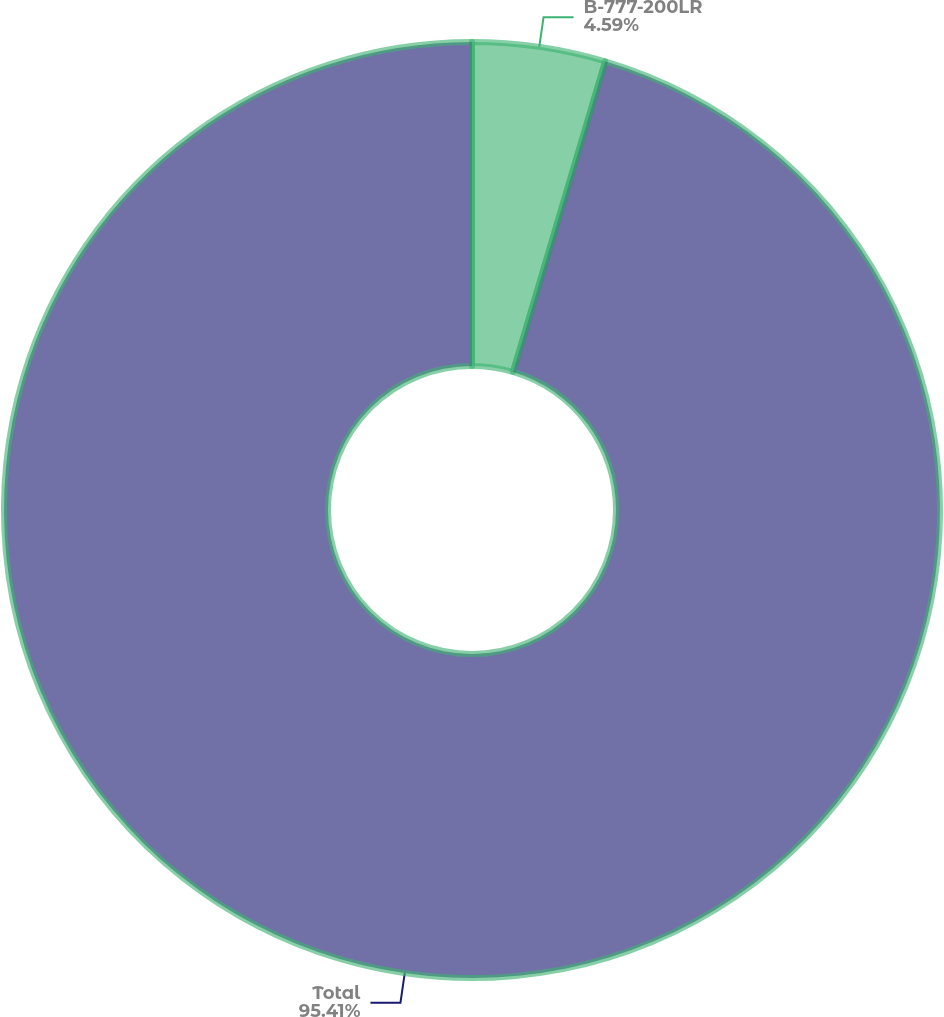Convert chart to OTSL. <chart><loc_0><loc_0><loc_500><loc_500><pie_chart><fcel>B-777-200LR<fcel>Total<nl><fcel>4.59%<fcel>95.41%<nl></chart> 